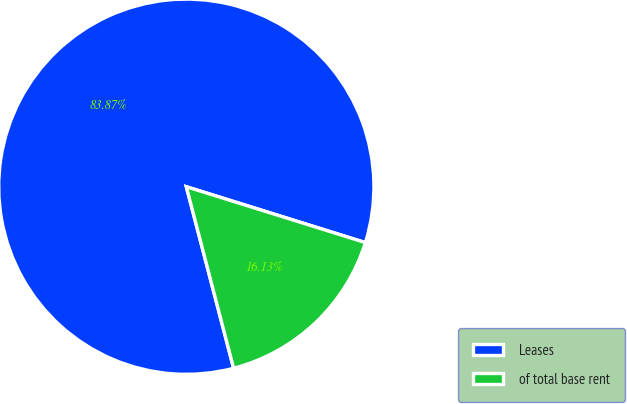Convert chart. <chart><loc_0><loc_0><loc_500><loc_500><pie_chart><fcel>Leases<fcel>of total base rent<nl><fcel>83.87%<fcel>16.13%<nl></chart> 